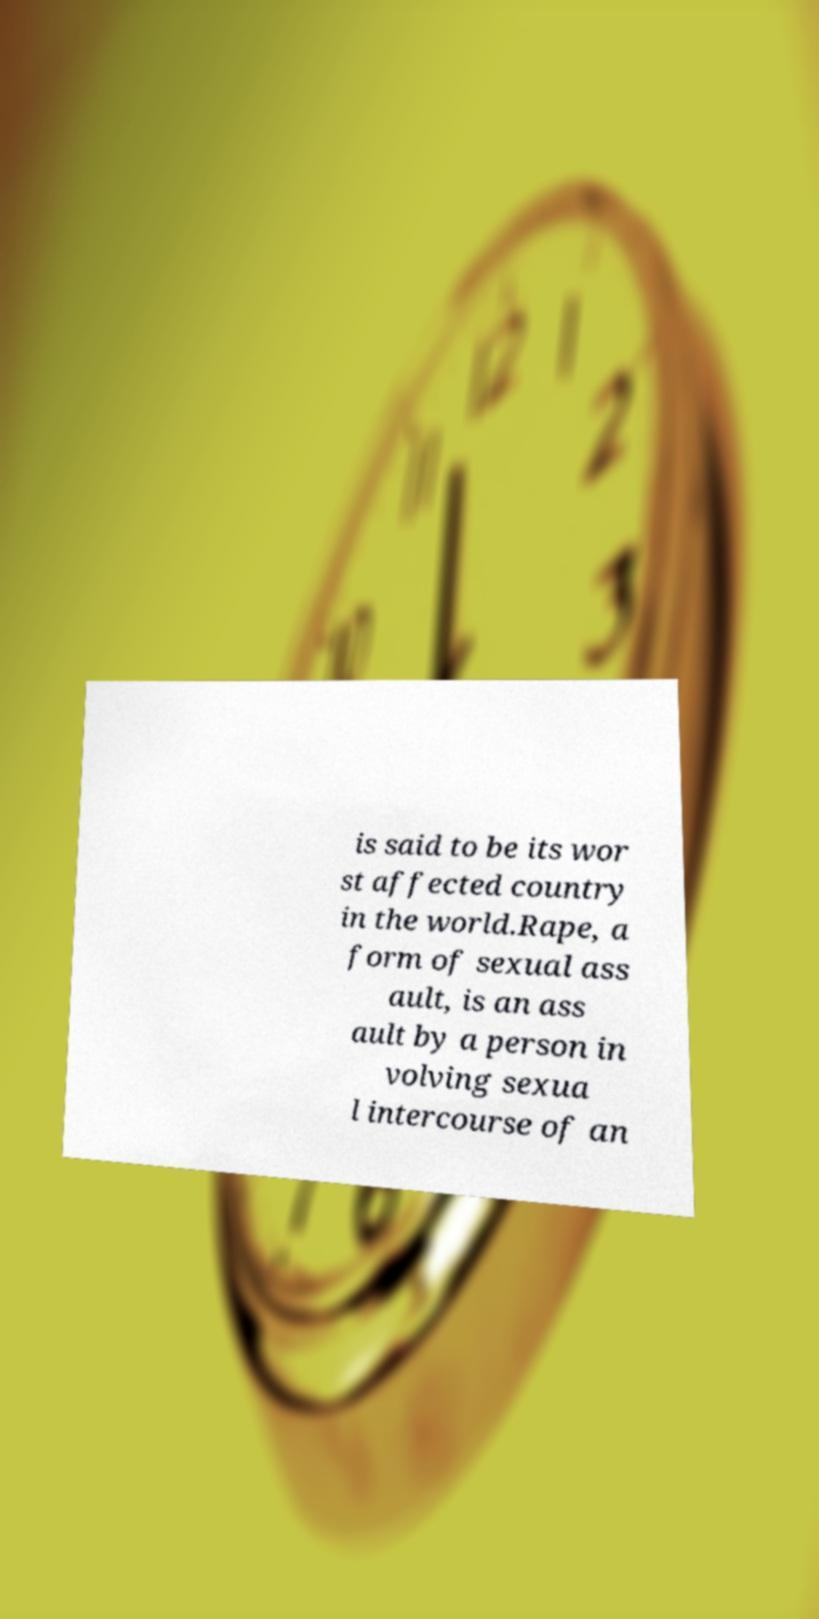I need the written content from this picture converted into text. Can you do that? is said to be its wor st affected country in the world.Rape, a form of sexual ass ault, is an ass ault by a person in volving sexua l intercourse of an 